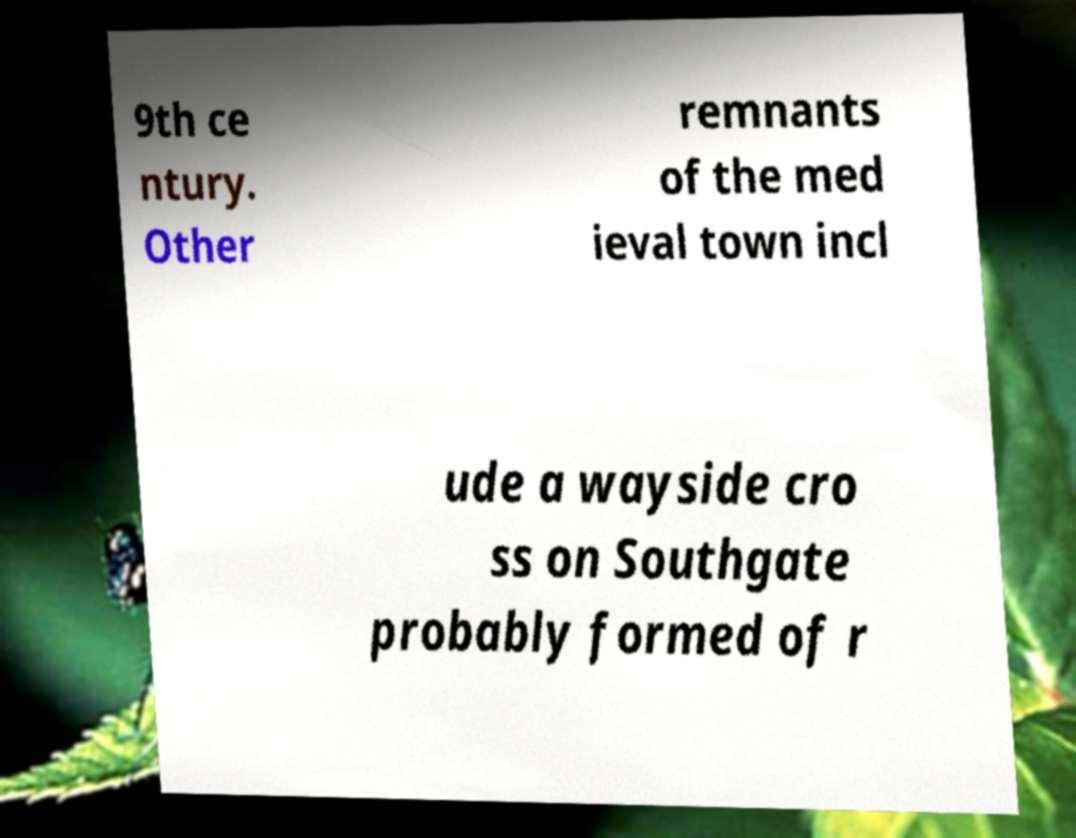Can you accurately transcribe the text from the provided image for me? 9th ce ntury. Other remnants of the med ieval town incl ude a wayside cro ss on Southgate probably formed of r 